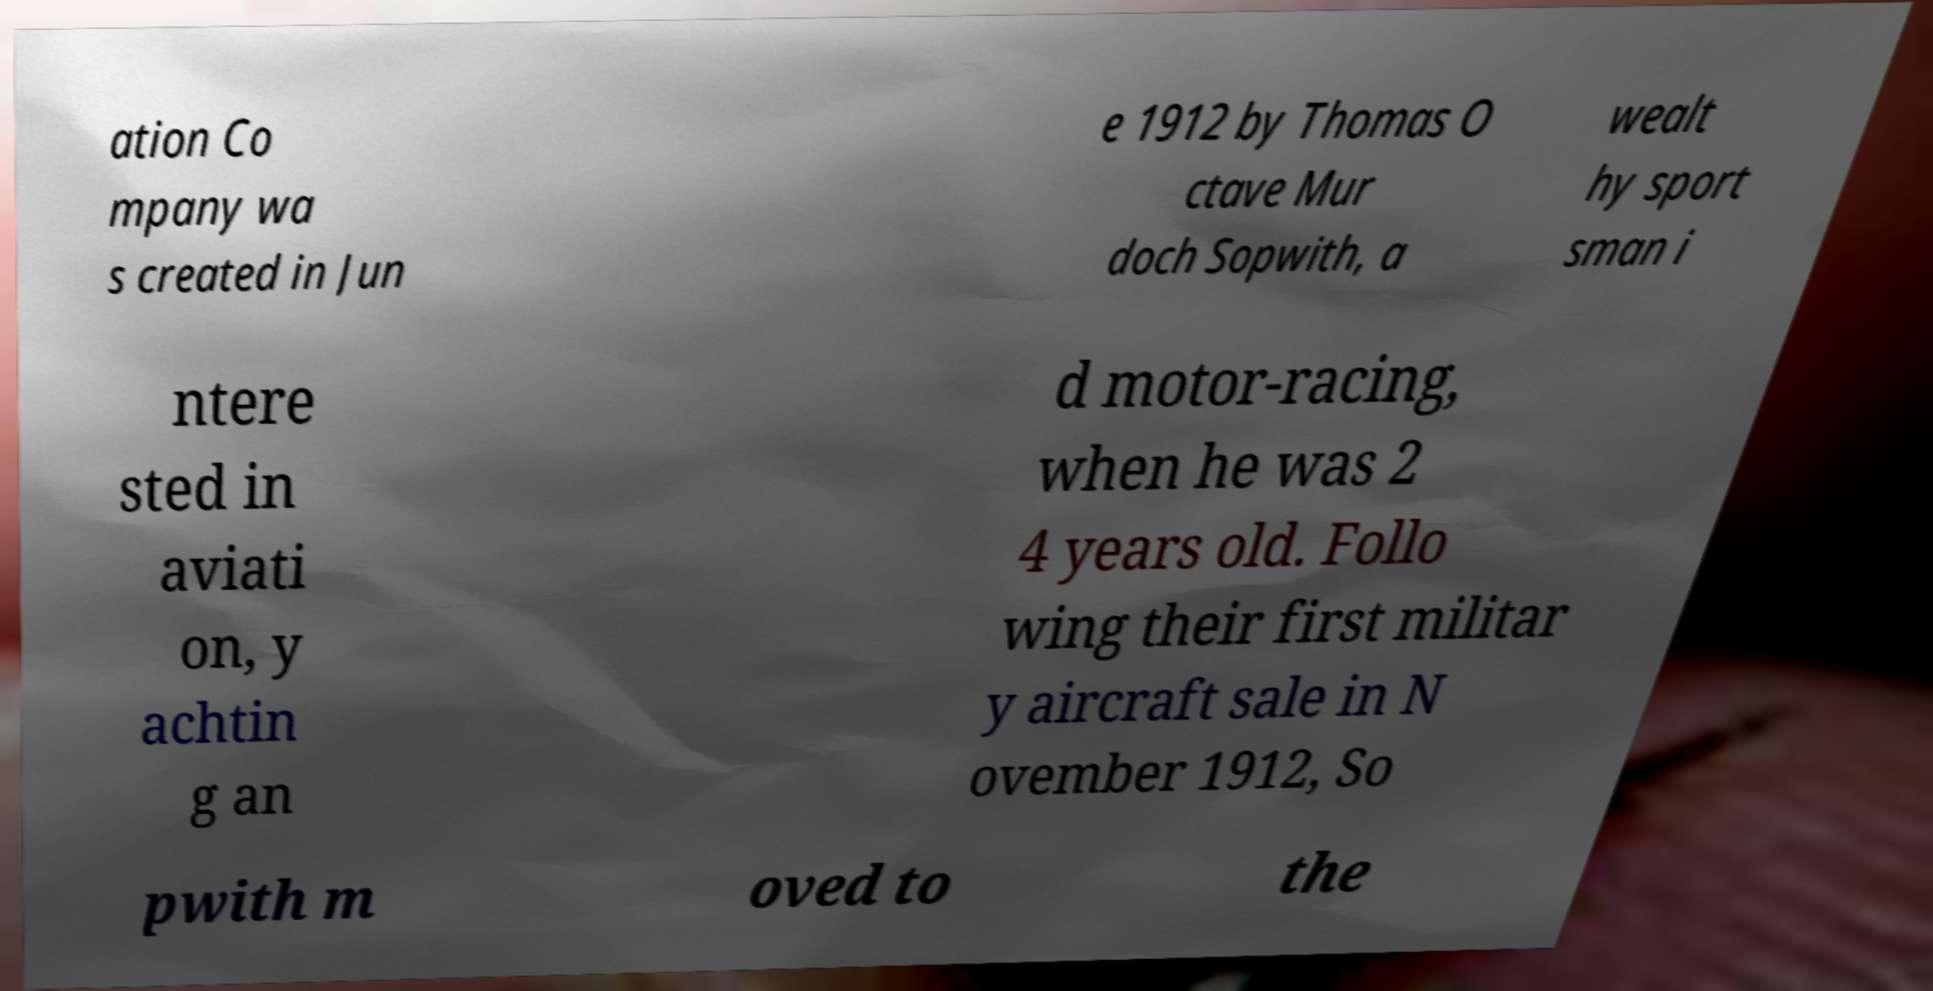What messages or text are displayed in this image? I need them in a readable, typed format. ation Co mpany wa s created in Jun e 1912 by Thomas O ctave Mur doch Sopwith, a wealt hy sport sman i ntere sted in aviati on, y achtin g an d motor-racing, when he was 2 4 years old. Follo wing their first militar y aircraft sale in N ovember 1912, So pwith m oved to the 